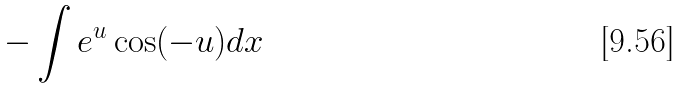<formula> <loc_0><loc_0><loc_500><loc_500>- \int e ^ { u } \cos ( - u ) d x</formula> 